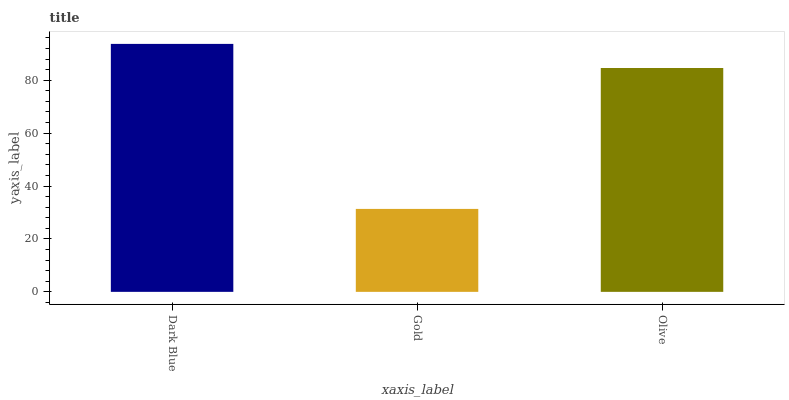Is Gold the minimum?
Answer yes or no. Yes. Is Dark Blue the maximum?
Answer yes or no. Yes. Is Olive the minimum?
Answer yes or no. No. Is Olive the maximum?
Answer yes or no. No. Is Olive greater than Gold?
Answer yes or no. Yes. Is Gold less than Olive?
Answer yes or no. Yes. Is Gold greater than Olive?
Answer yes or no. No. Is Olive less than Gold?
Answer yes or no. No. Is Olive the high median?
Answer yes or no. Yes. Is Olive the low median?
Answer yes or no. Yes. Is Dark Blue the high median?
Answer yes or no. No. Is Dark Blue the low median?
Answer yes or no. No. 